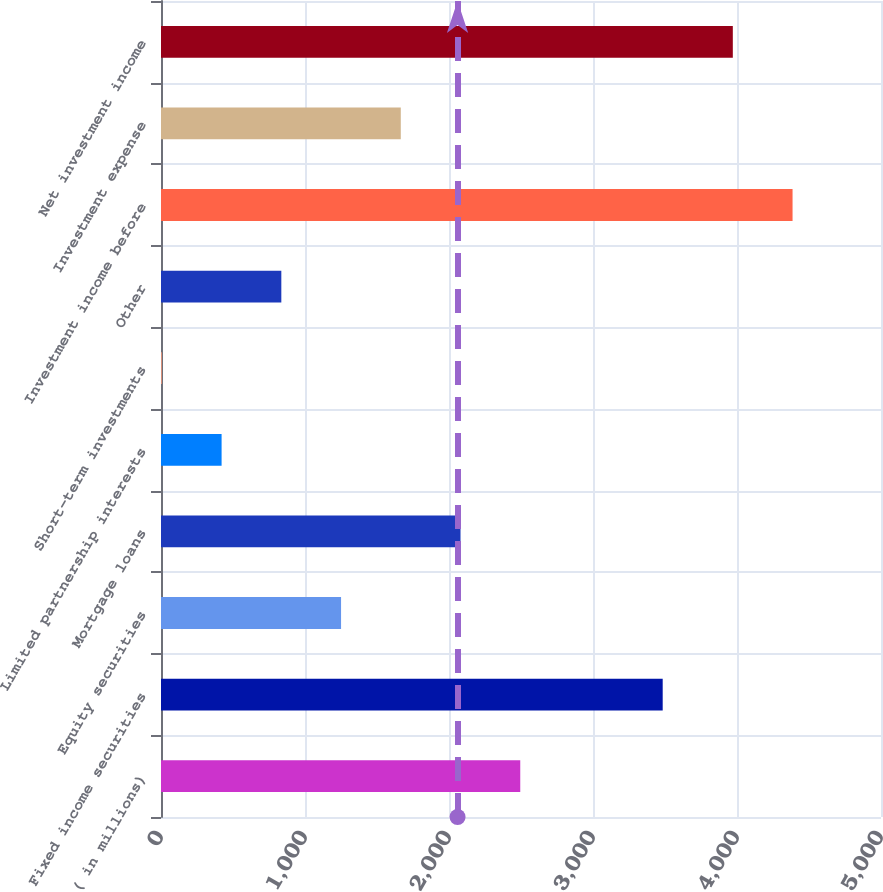Convert chart. <chart><loc_0><loc_0><loc_500><loc_500><bar_chart><fcel>( in millions)<fcel>Fixed income securities<fcel>Equity securities<fcel>Mortgage loans<fcel>Limited partnership interests<fcel>Short-term investments<fcel>Other<fcel>Investment income before<fcel>Investment expense<fcel>Net investment income<nl><fcel>2494.8<fcel>3484<fcel>1250.4<fcel>2080<fcel>420.8<fcel>6<fcel>835.6<fcel>4385.8<fcel>1665.2<fcel>3971<nl></chart> 